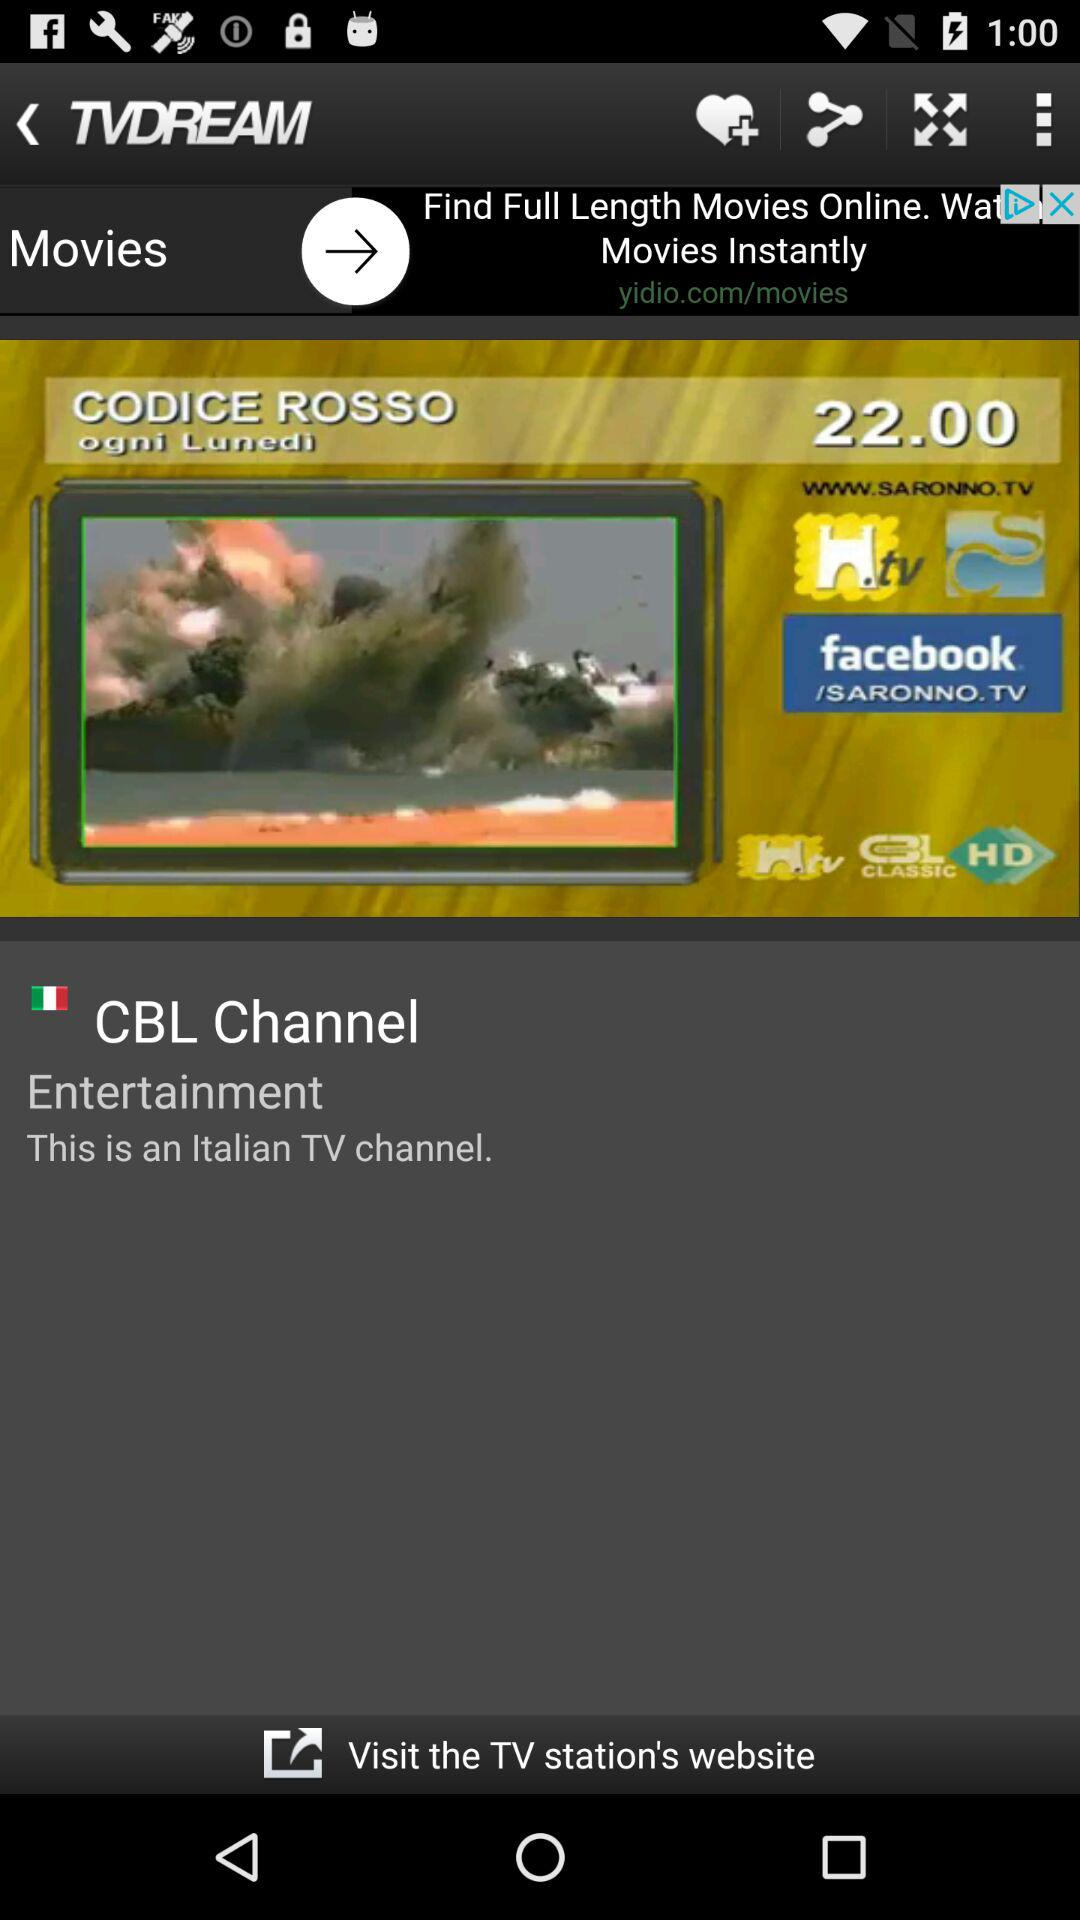What genre it is?
When the provided information is insufficient, respond with <no answer>. <no answer> 